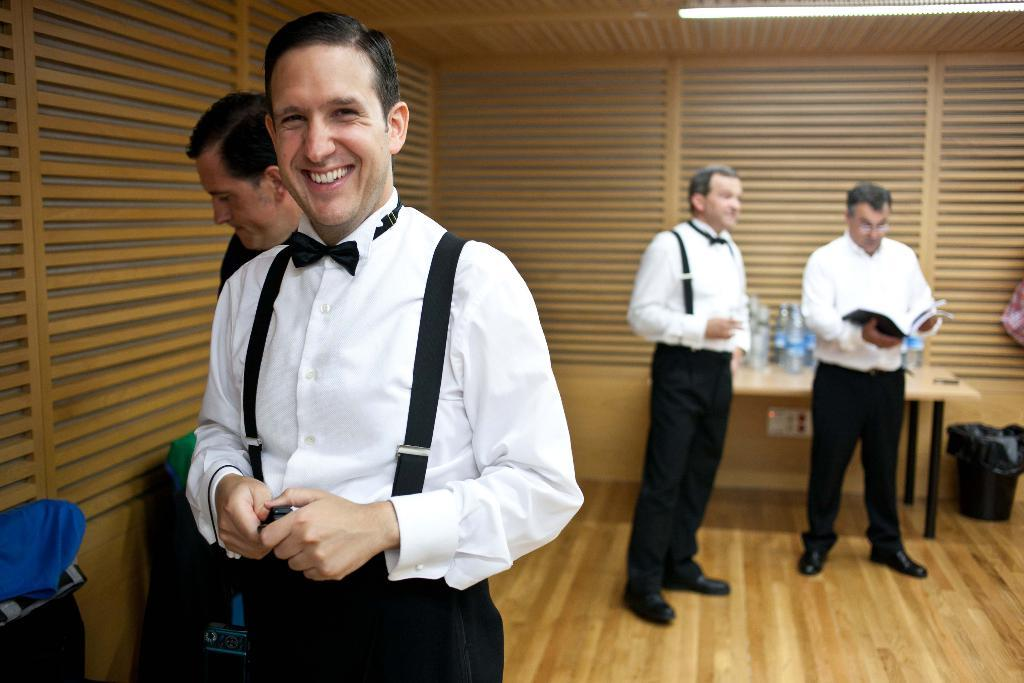Who is present in the image? There is a man in the image. What is the man doing in the image? The man is smiling in the image. What can be seen in the background of the image? There are people, a table, a dustbin, bottles, a wall, and windows visible in the background. What type of sofa can be seen in the image? There is no sofa present in the image. What songs are being sung by the people in the background? There is no indication of any songs being sung in the image; we can only see people in the background. 